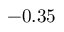Convert formula to latex. <formula><loc_0><loc_0><loc_500><loc_500>- 0 . 3 5</formula> 